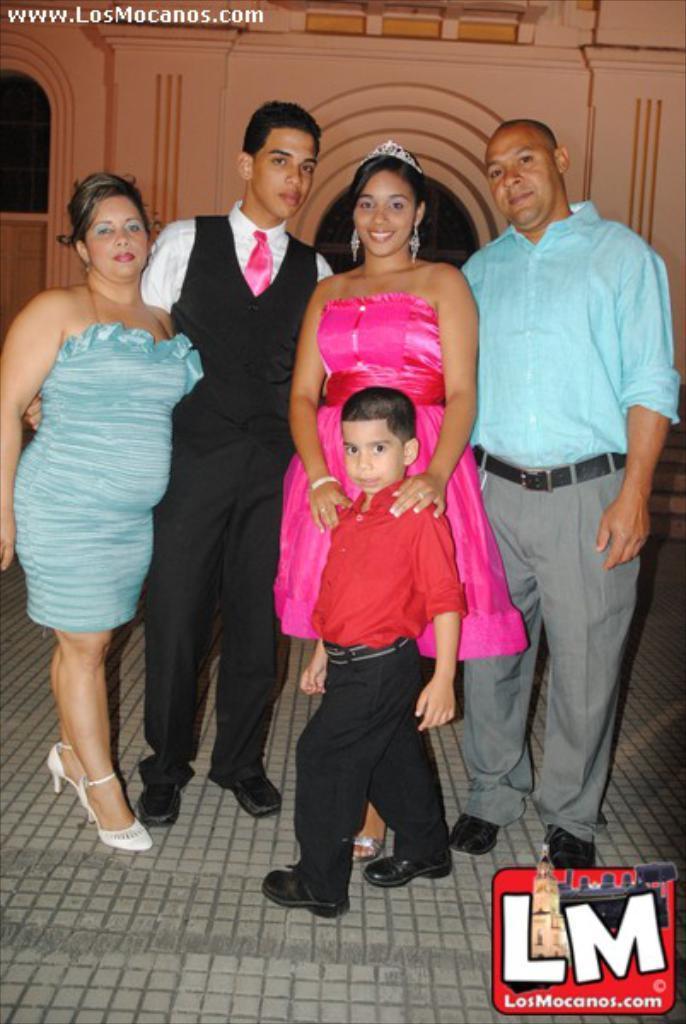Please provide a concise description of this image. In the foreground of this image, there are two men, two women and a boy standing on the pavement and posing to a camera. In the background, there is a wall of a building. 